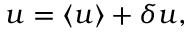Convert formula to latex. <formula><loc_0><loc_0><loc_500><loc_500>u = \langle u \rangle + \delta u ,</formula> 